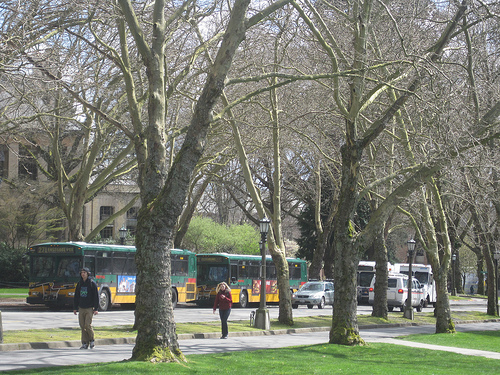What is the weather like in the picture? The weather in the image appears to be quite pleasant; there's ample sunshine filtering through the tree branches, casting soft shadows on the ground, and the sky seems mostly clear, hinting at a nice day, perhaps in the early throes of spring. 